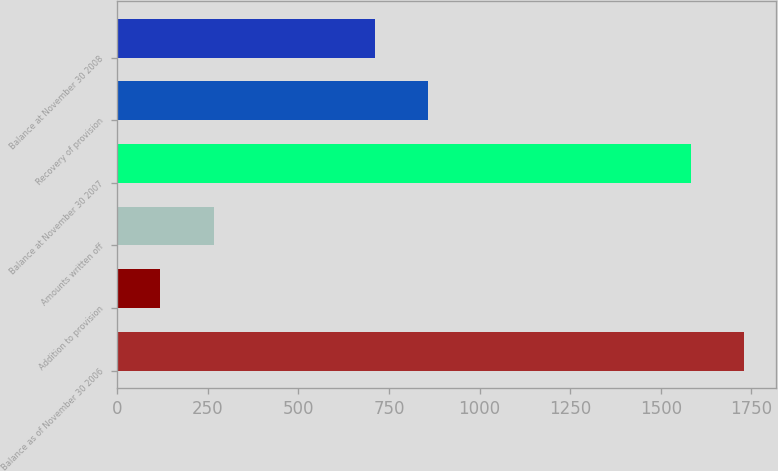Convert chart. <chart><loc_0><loc_0><loc_500><loc_500><bar_chart><fcel>Balance as of November 30 2006<fcel>Addition to provision<fcel>Amounts written off<fcel>Balance at November 30 2007<fcel>Recovery of provision<fcel>Balance at November 30 2008<nl><fcel>1730.9<fcel>119<fcel>265.9<fcel>1584<fcel>858.9<fcel>712<nl></chart> 